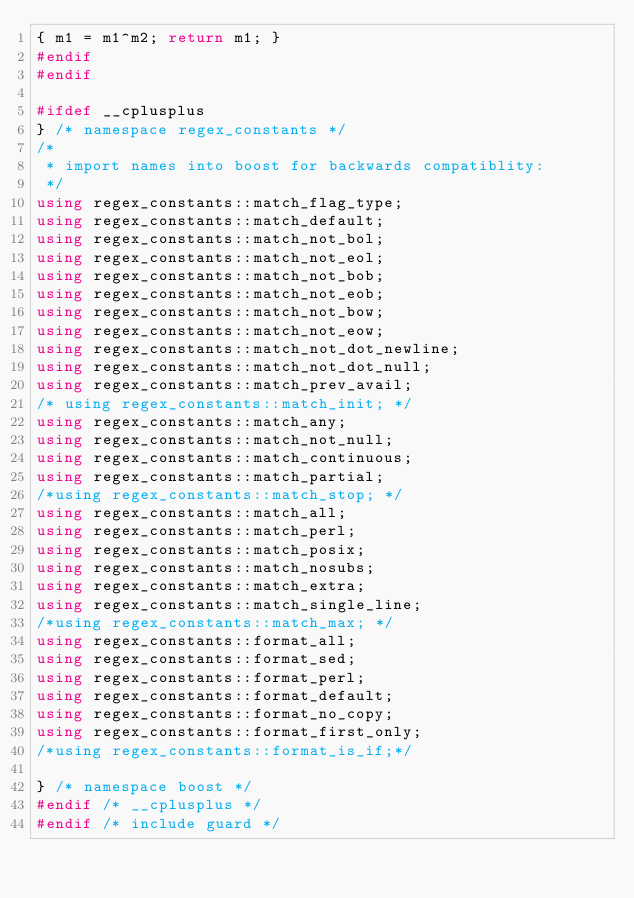<code> <loc_0><loc_0><loc_500><loc_500><_C++_>{ m1 = m1^m2; return m1; }
#endif
#endif

#ifdef __cplusplus
} /* namespace regex_constants */
/*
 * import names into boost for backwards compatiblity:
 */
using regex_constants::match_flag_type;
using regex_constants::match_default;
using regex_constants::match_not_bol;
using regex_constants::match_not_eol;
using regex_constants::match_not_bob;
using regex_constants::match_not_eob;
using regex_constants::match_not_bow;
using regex_constants::match_not_eow;
using regex_constants::match_not_dot_newline;
using regex_constants::match_not_dot_null;
using regex_constants::match_prev_avail;
/* using regex_constants::match_init; */
using regex_constants::match_any;
using regex_constants::match_not_null;
using regex_constants::match_continuous;
using regex_constants::match_partial;
/*using regex_constants::match_stop; */
using regex_constants::match_all;
using regex_constants::match_perl;
using regex_constants::match_posix;
using regex_constants::match_nosubs;
using regex_constants::match_extra;
using regex_constants::match_single_line;
/*using regex_constants::match_max; */
using regex_constants::format_all;
using regex_constants::format_sed;
using regex_constants::format_perl;
using regex_constants::format_default;
using regex_constants::format_no_copy;
using regex_constants::format_first_only;
/*using regex_constants::format_is_if;*/

} /* namespace boost */
#endif /* __cplusplus */
#endif /* include guard */

</code> 